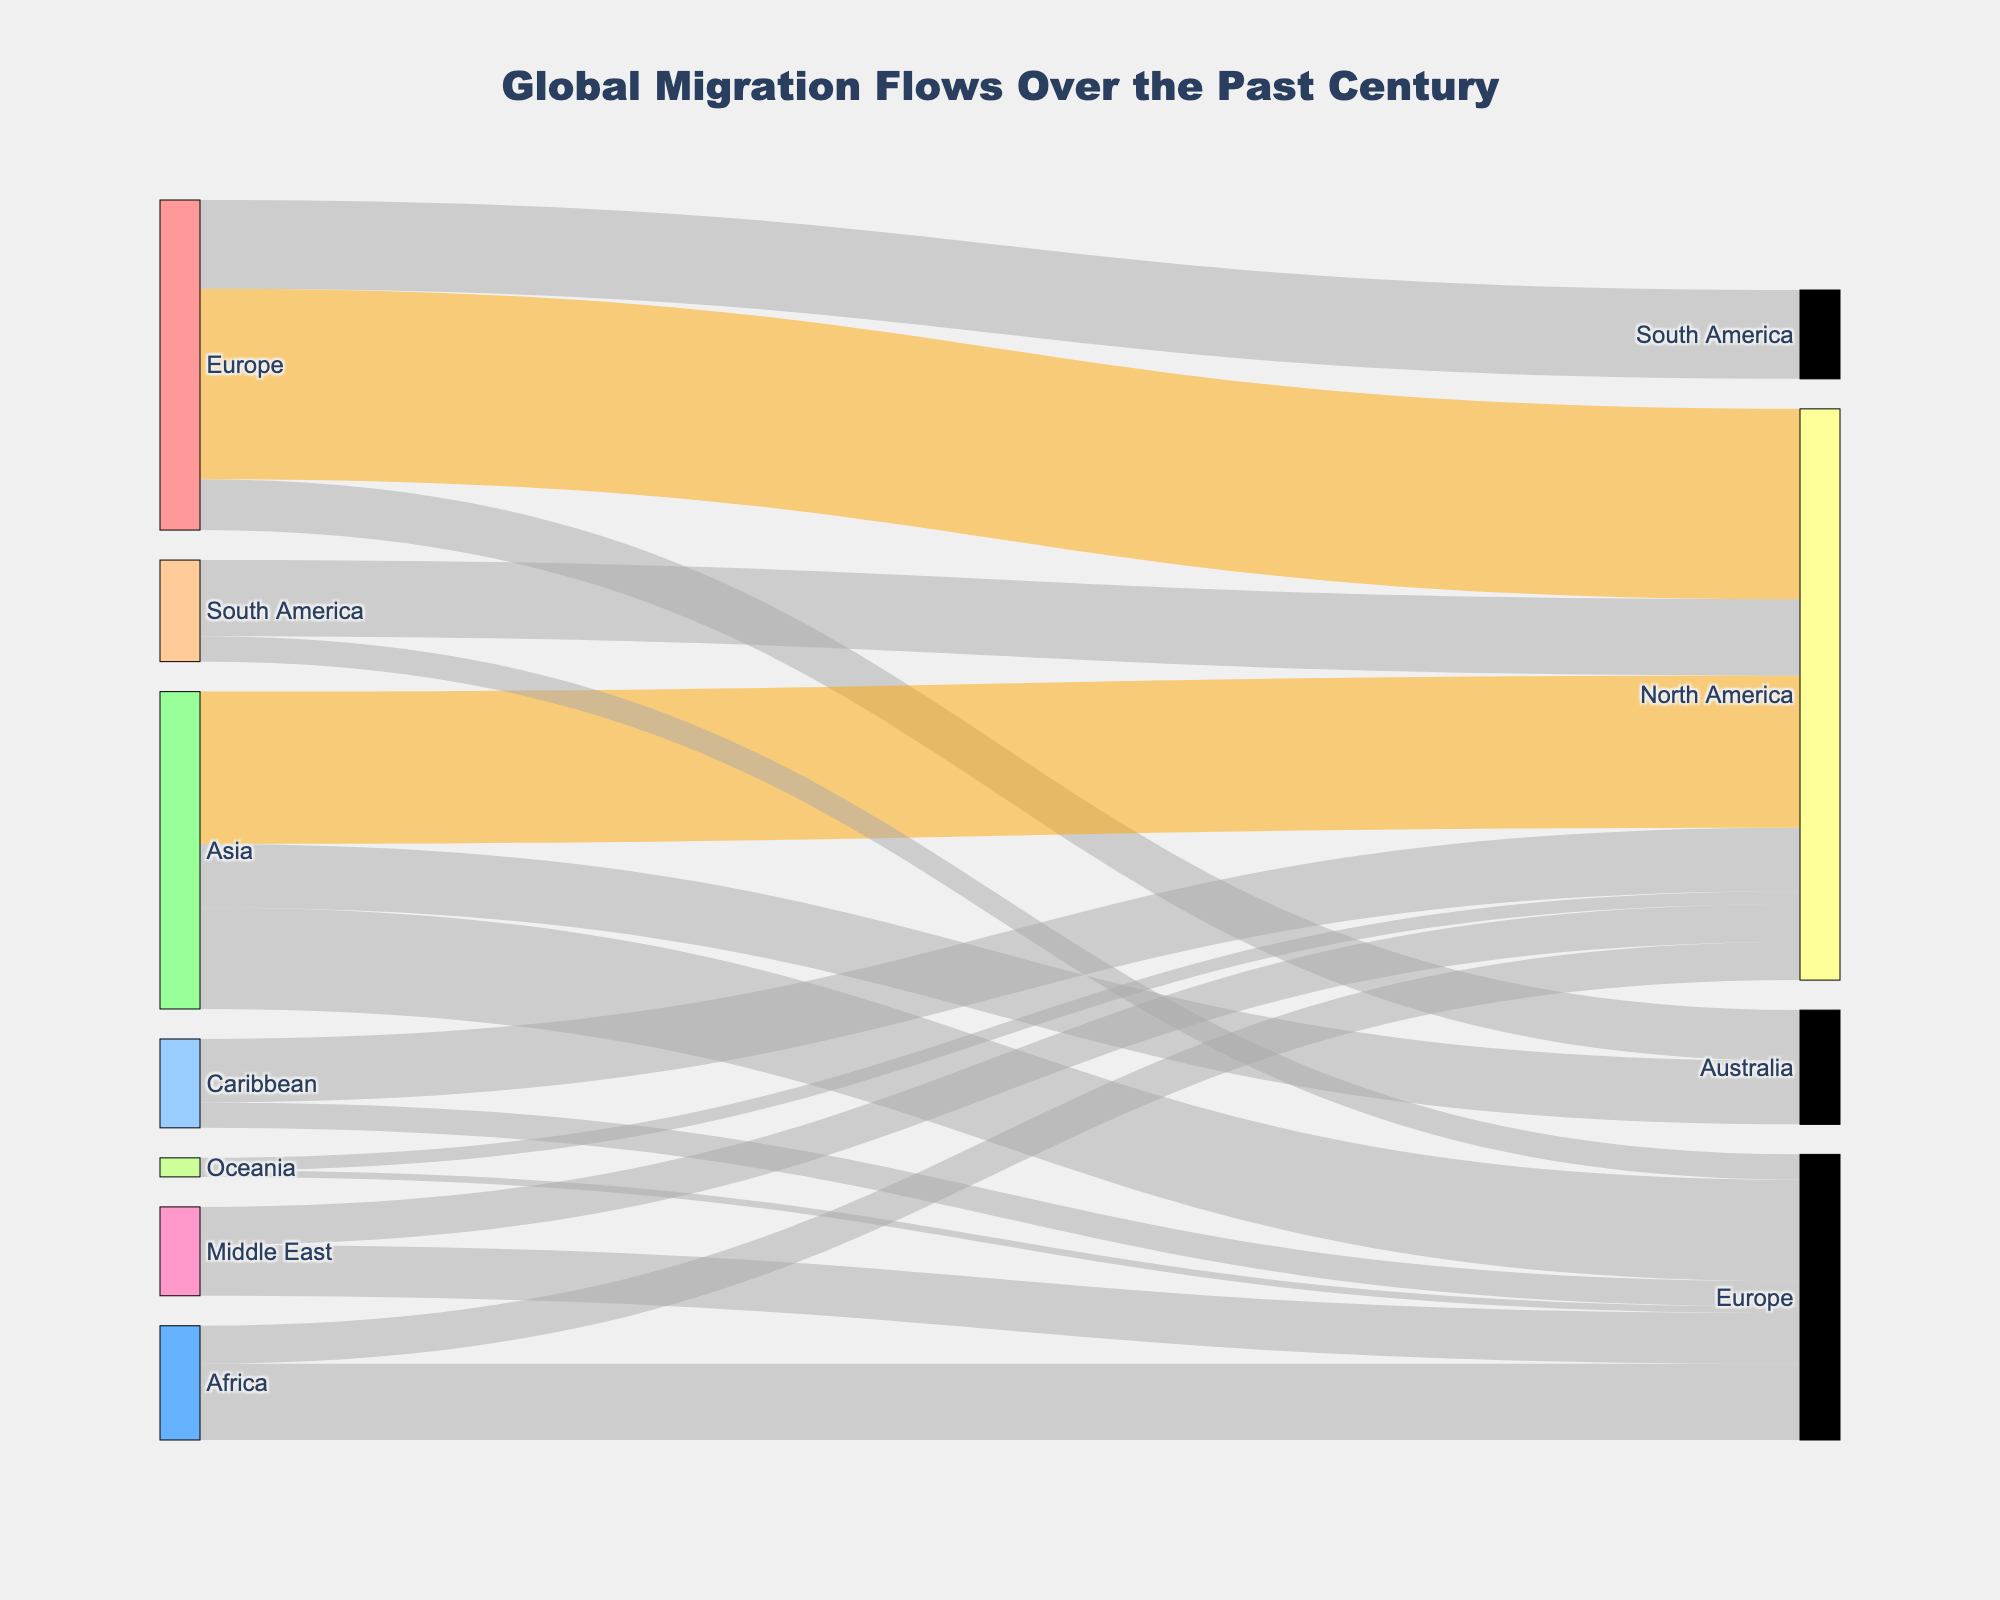what is the title of the figure? The title is displayed at the top of the figure and provides a summary of the chart.
Answer: Global Migration Flows Over the Past Century which regions have migration flows greater than 10 million? The color hint is given as 'rgba(255,165,0,0.5)' for values greater than 10 million. These are Europe to North America, Asia to North America, and Asia to Europe.
Answer: Europe to North America, Asia to North America, Asia to Europe how many regions are involved in migration flows to North America? By counting the sources linked to the North America node, we identify Europe, Africa, Asia, South America, the Middle East, the Caribbean, Oceania.
Answer: 7 what is the total migration flow from Europe to various regions? Add the migration values from Europe to North America, South America, and Australia: 15,000,000 + 7,000,000 + 4,000,000 = 26,000,000.
Answer: 26,000,000 which region has the highest migration inflow from Asia? Look for the largest migration value originating from Asia and ending in another region. Asia to North America has the highest value with 12,000,000.
Answer: North America how does the migration flow from Africa to Europe compare to that from Africa to North America? Compare the two values: Africa to Europe is 6,000,000 and Africa to North America is 3,000,000.
Answer: Africa to Europe is greater which destination region has the smallest migration inflow from various sources? From the link values, Europe receives the smallest inflow from Oceania with 500,000.
Answer: Europe from Oceania what is the average migration flow value from South America to other regions? Sum the values and divide by the number of flows: (6,000,000 + 2,000,000) / 2 = 4,000,000.
Answer: 4,000,000 how does the migration flow from Europe to South America compare to that from South America to North America? 7,000,000 from Europe to South America and 6,000,000 from South America to North America.
Answer: Europe to South America is greater 